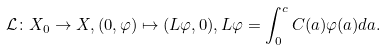Convert formula to latex. <formula><loc_0><loc_0><loc_500><loc_500>\mathcal { L } \colon X _ { 0 } \to X , ( 0 , \varphi ) \mapsto ( L \varphi , 0 ) , L \varphi = \int _ { 0 } ^ { c } C ( a ) \varphi ( a ) d a .</formula> 